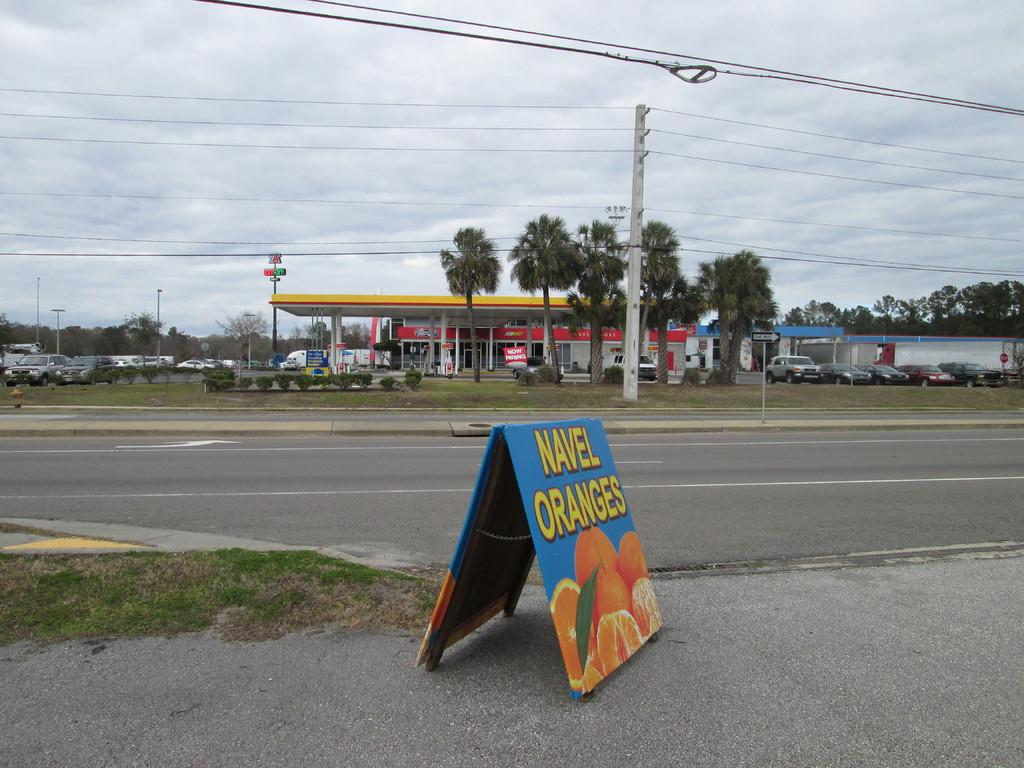<image>
Create a compact narrative representing the image presented. A blue sign on the street that says navel oranges with a picture of oranges on the bottom. 